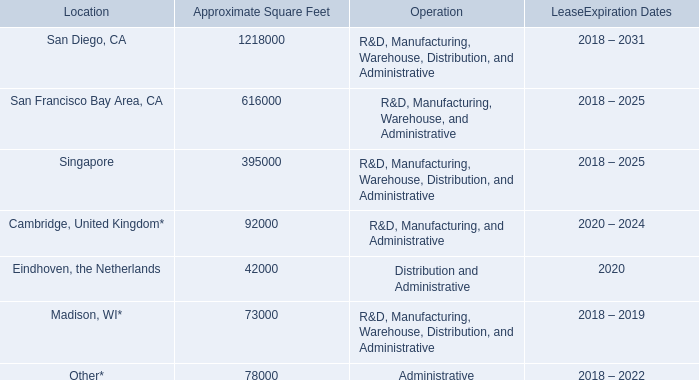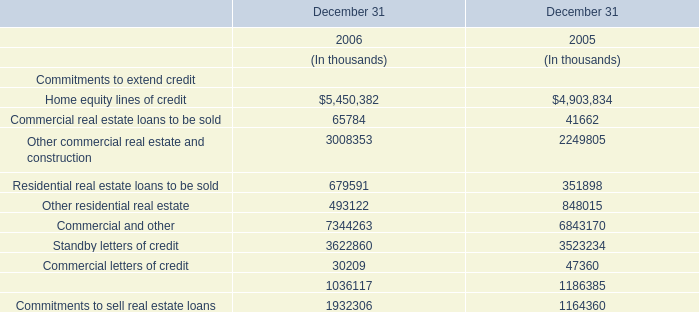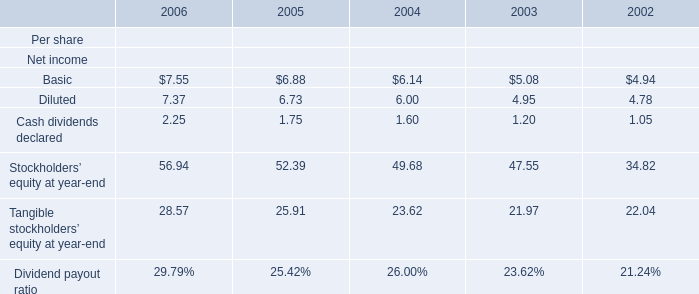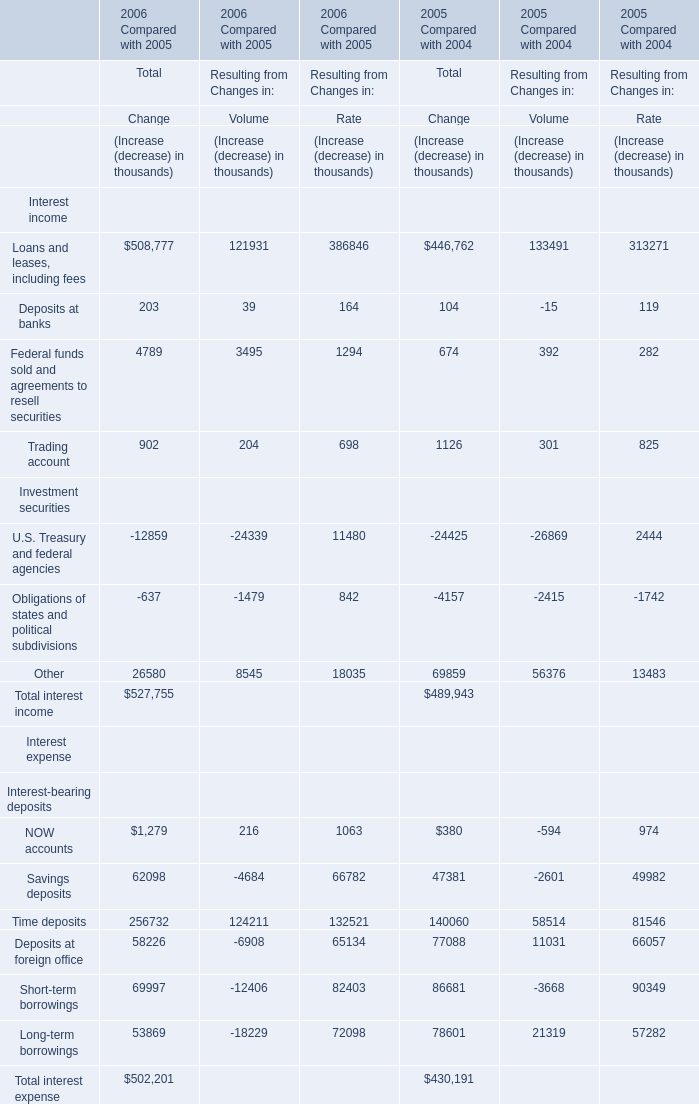In the section with higher amount of Total Change of Total interest income, what's the sum of Total Change of Total interest expense? (in thousand) 
Answer: 502201. 